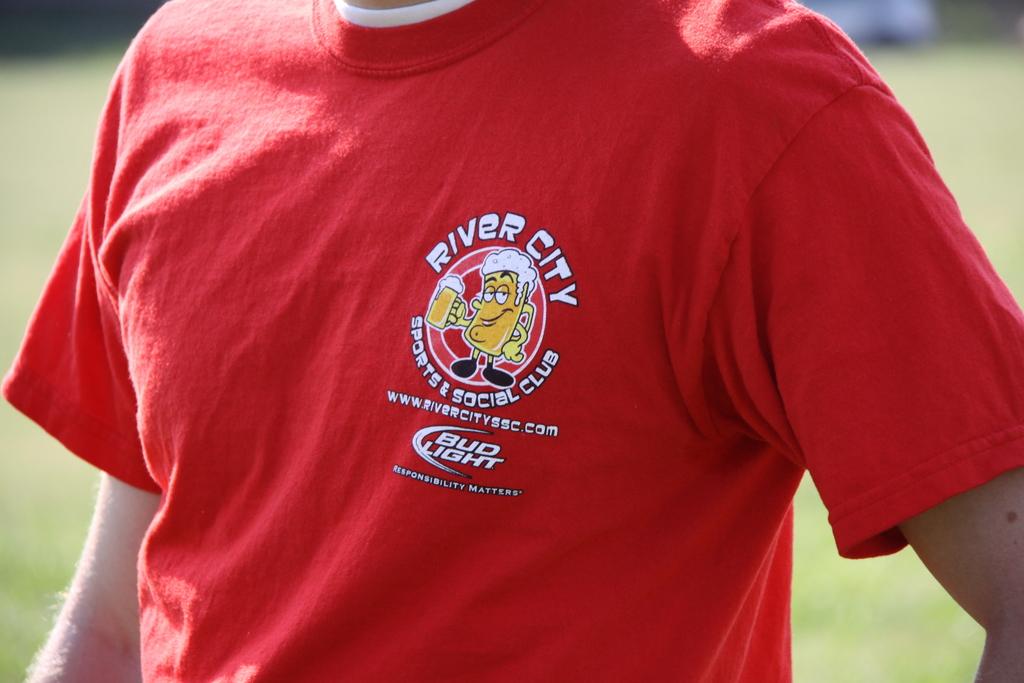What is the website printed on his shirt?
Give a very brief answer. Www.rivercityssc.com. 